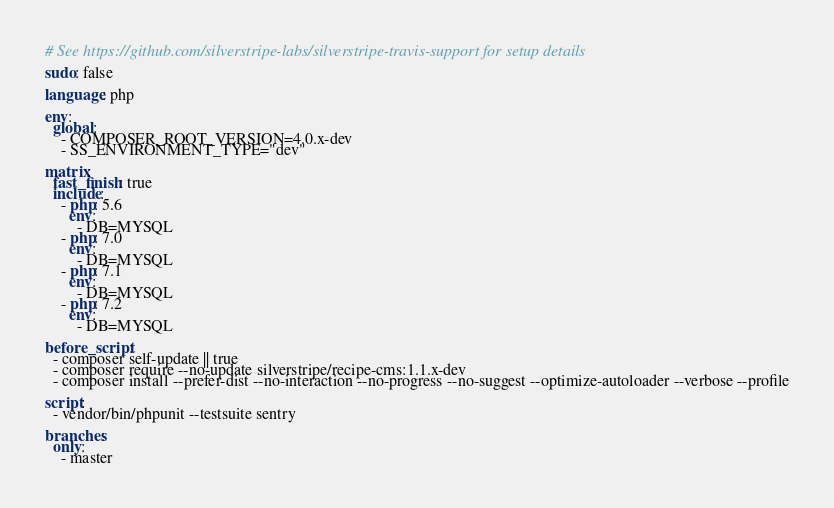<code> <loc_0><loc_0><loc_500><loc_500><_YAML_># See https://github.com/silverstripe-labs/silverstripe-travis-support for setup details

sudo: false

language: php

env:
  global:
    - COMPOSER_ROOT_VERSION=4.0.x-dev
    - SS_ENVIRONMENT_TYPE="dev"

matrix:
  fast_finish: true
  include:
    - php: 5.6
      env:
        - DB=MYSQL
    - php: 7.0
      env:
        - DB=MYSQL
    - php: 7.1
      env:
        - DB=MYSQL
    - php: 7.2
      env:
        - DB=MYSQL

before_script:
  - composer self-update || true
  - composer require --no-update silverstripe/recipe-cms:1.1.x-dev
  - composer install --prefer-dist --no-interaction --no-progress --no-suggest --optimize-autoloader --verbose --profile

script:
  - vendor/bin/phpunit --testsuite sentry

branches:
  only: 
    - master
</code> 